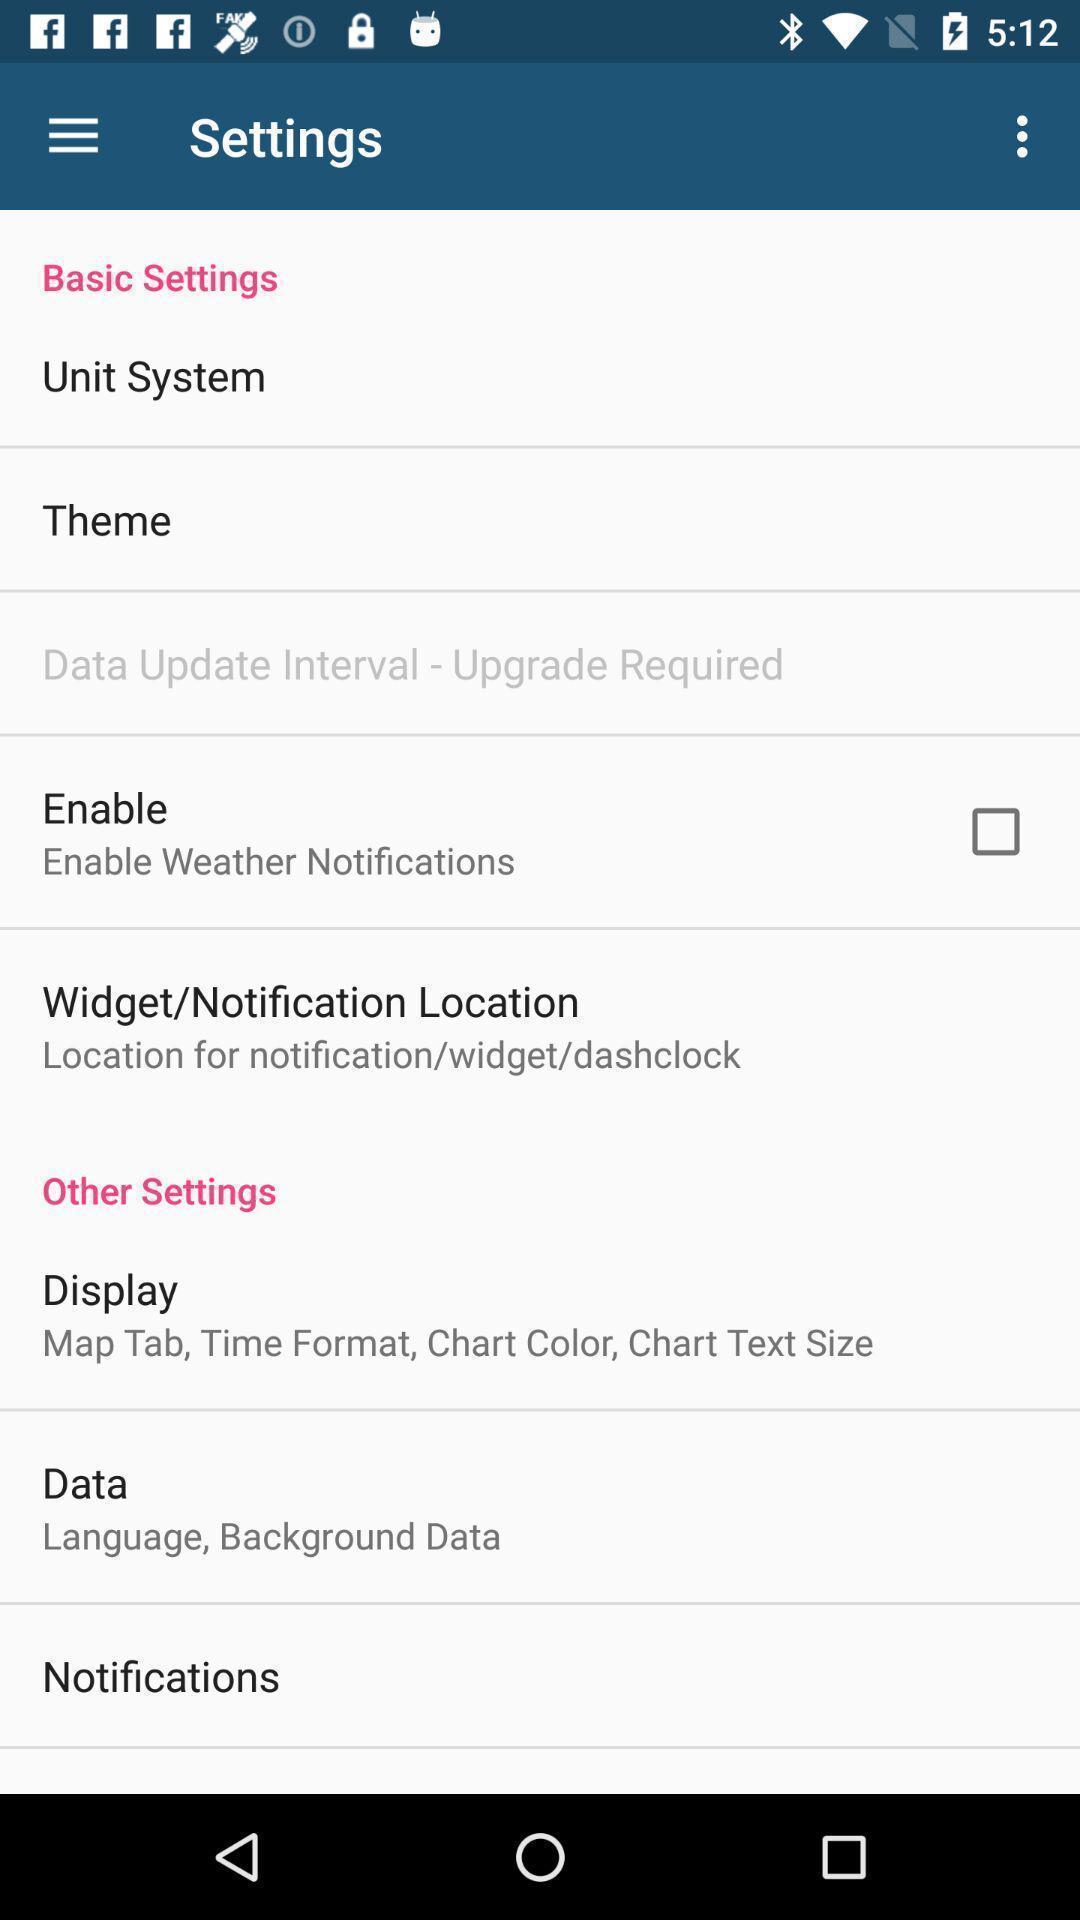What can you discern from this picture? Screen showing settings page. 